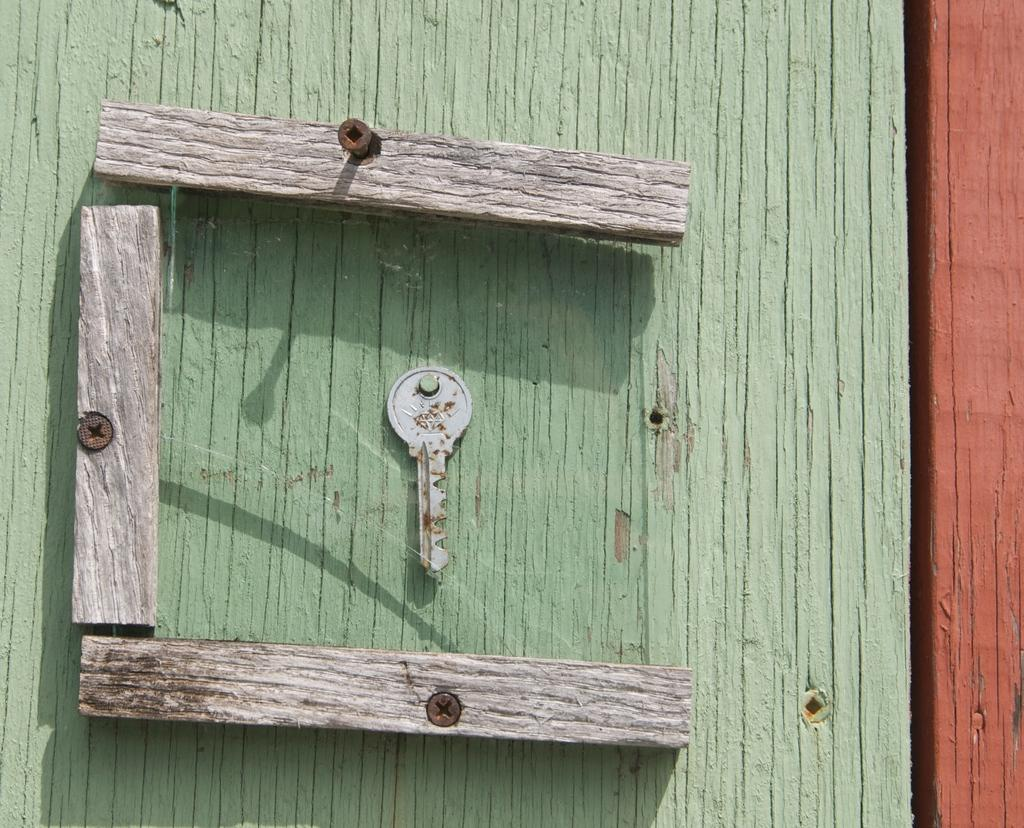What object can be seen in the image that is often used to unlock doors? There is a key in the image. What type of material are the sticks made of in the image? The sticks in the image are made of wood. What type of fasteners are present in the image? There are screws in the image. What can be seen in the background of the image? There is a wall visible in the background of the image. What flavor of ice cream is being sold at the stand in the image? There is no ice cream stand present in the image, so it is not possible to determine the flavor of ice cream being sold. 